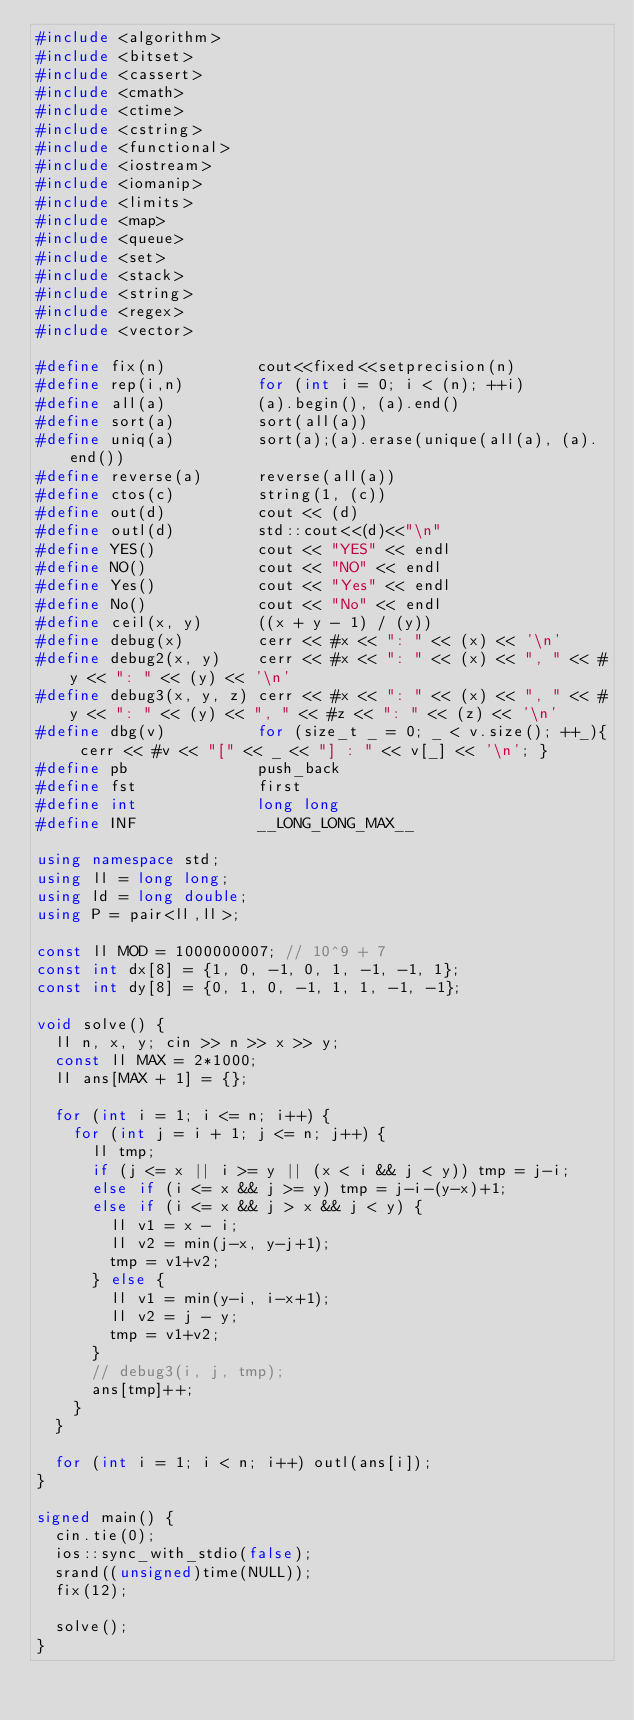<code> <loc_0><loc_0><loc_500><loc_500><_C++_>#include <algorithm>
#include <bitset>
#include <cassert>
#include <cmath>
#include <ctime>
#include <cstring>
#include <functional>
#include <iostream>
#include <iomanip>
#include <limits>
#include <map>
#include <queue>
#include <set>
#include <stack>
#include <string>
#include <regex>
#include <vector>

#define fix(n)          cout<<fixed<<setprecision(n)
#define rep(i,n)        for (int i = 0; i < (n); ++i)
#define all(a)          (a).begin(), (a).end()
#define sort(a)         sort(all(a))
#define uniq(a)         sort(a);(a).erase(unique(all(a), (a).end())
#define reverse(a)      reverse(all(a))
#define ctos(c)         string(1, (c))
#define out(d)          cout << (d)
#define outl(d)         std::cout<<(d)<<"\n"
#define YES()           cout << "YES" << endl
#define NO()            cout << "NO" << endl
#define Yes()           cout << "Yes" << endl
#define No()            cout << "No" << endl
#define ceil(x, y)      ((x + y - 1) / (y))
#define debug(x)        cerr << #x << ": " << (x) << '\n'
#define debug2(x, y)    cerr << #x << ": " << (x) << ", " << #y << ": " << (y) << '\n'
#define debug3(x, y, z) cerr << #x << ": " << (x) << ", " << #y << ": " << (y) << ", " << #z << ": " << (z) << '\n'
#define dbg(v)          for (size_t _ = 0; _ < v.size(); ++_){ cerr << #v << "[" << _ << "] : " << v[_] << '\n'; }
#define pb              push_back
#define fst             first
#define int             long long
#define INF             __LONG_LONG_MAX__

using namespace std;
using ll = long long;
using ld = long double;
using P = pair<ll,ll>;

const ll MOD = 1000000007; // 10^9 + 7
const int dx[8] = {1, 0, -1, 0, 1, -1, -1, 1};
const int dy[8] = {0, 1, 0, -1, 1, 1, -1, -1};

void solve() {
  ll n, x, y; cin >> n >> x >> y;
  const ll MAX = 2*1000;
  ll ans[MAX + 1] = {};

  for (int i = 1; i <= n; i++) {
    for (int j = i + 1; j <= n; j++) {
      ll tmp;
      if (j <= x || i >= y || (x < i && j < y)) tmp = j-i;
      else if (i <= x && j >= y) tmp = j-i-(y-x)+1;
      else if (i <= x && j > x && j < y) {
        ll v1 = x - i;
        ll v2 = min(j-x, y-j+1);
        tmp = v1+v2;
      } else {
        ll v1 = min(y-i, i-x+1);
        ll v2 = j - y;
        tmp = v1+v2;
      }
      // debug3(i, j, tmp);
      ans[tmp]++;
    }
  }

  for (int i = 1; i < n; i++) outl(ans[i]);
}

signed main() {
  cin.tie(0);
  ios::sync_with_stdio(false);
  srand((unsigned)time(NULL));
  fix(12);

  solve();
}
</code> 